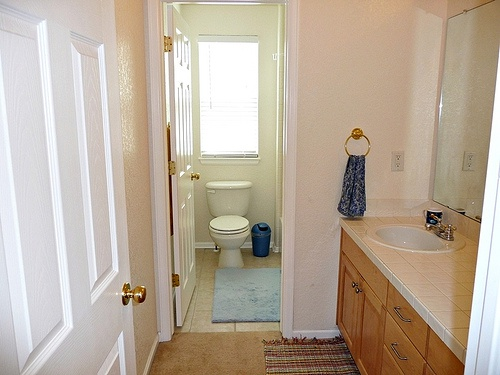Describe the objects in this image and their specific colors. I can see toilet in darkgray, tan, gray, and beige tones, sink in darkgray, tan, and olive tones, and cup in darkgray, black, gray, and maroon tones in this image. 